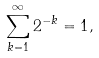<formula> <loc_0><loc_0><loc_500><loc_500>\sum _ { k = 1 } ^ { \infty } 2 ^ { - k } = 1 ,</formula> 